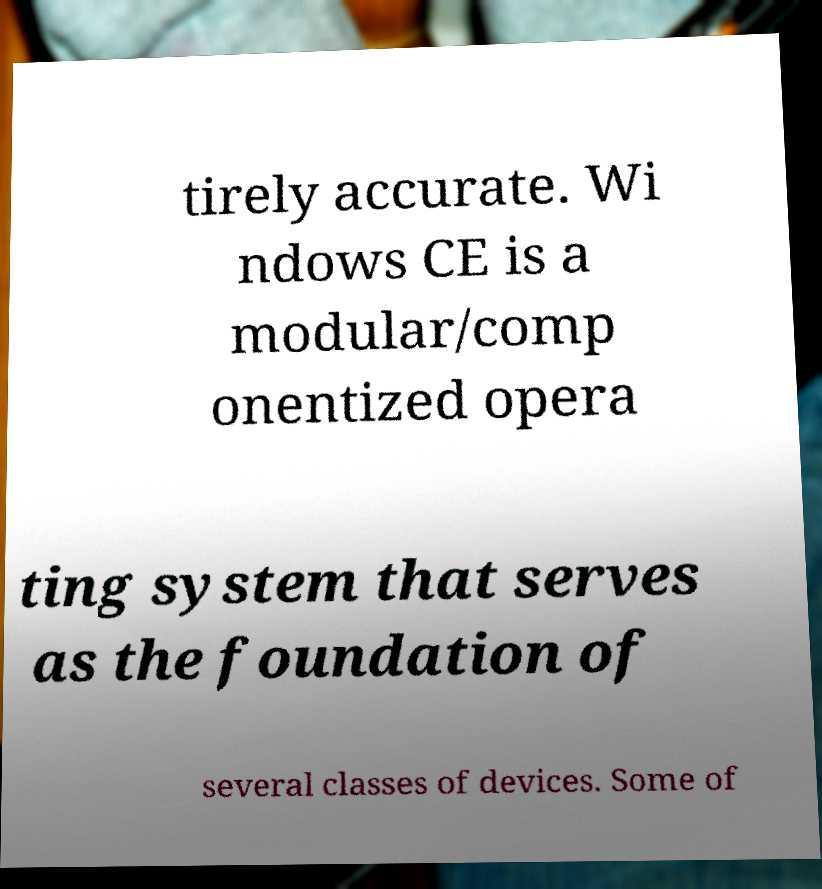There's text embedded in this image that I need extracted. Can you transcribe it verbatim? tirely accurate. Wi ndows CE is a modular/comp onentized opera ting system that serves as the foundation of several classes of devices. Some of 